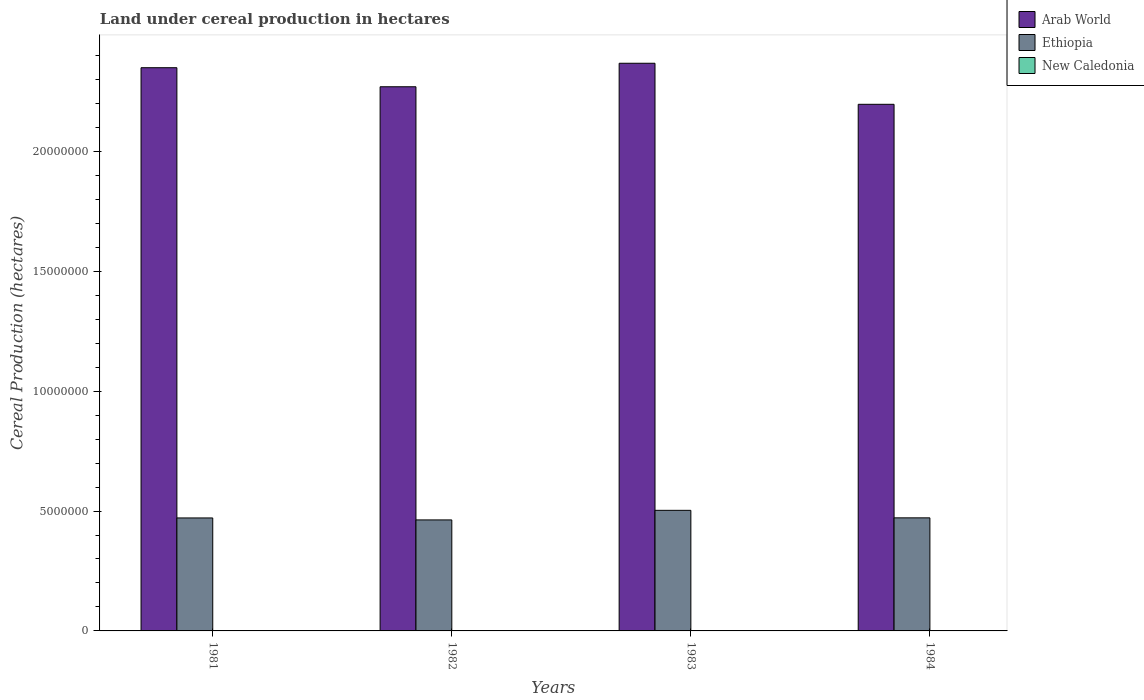Are the number of bars per tick equal to the number of legend labels?
Offer a terse response. Yes. Are the number of bars on each tick of the X-axis equal?
Offer a very short reply. Yes. How many bars are there on the 3rd tick from the left?
Keep it short and to the point. 3. What is the land under cereal production in Arab World in 1984?
Give a very brief answer. 2.20e+07. Across all years, what is the maximum land under cereal production in Ethiopia?
Offer a very short reply. 5.03e+06. Across all years, what is the minimum land under cereal production in Arab World?
Offer a very short reply. 2.20e+07. In which year was the land under cereal production in Arab World maximum?
Provide a short and direct response. 1983. What is the total land under cereal production in Arab World in the graph?
Your answer should be very brief. 9.18e+07. What is the difference between the land under cereal production in Ethiopia in 1982 and that in 1983?
Your response must be concise. -4.00e+05. What is the difference between the land under cereal production in Arab World in 1982 and the land under cereal production in New Caledonia in 1984?
Offer a very short reply. 2.27e+07. What is the average land under cereal production in New Caledonia per year?
Make the answer very short. 1174.75. In the year 1984, what is the difference between the land under cereal production in New Caledonia and land under cereal production in Arab World?
Your answer should be compact. -2.20e+07. In how many years, is the land under cereal production in Ethiopia greater than 16000000 hectares?
Give a very brief answer. 0. What is the ratio of the land under cereal production in Ethiopia in 1982 to that in 1983?
Make the answer very short. 0.92. Is the land under cereal production in Arab World in 1983 less than that in 1984?
Ensure brevity in your answer.  No. Is the difference between the land under cereal production in New Caledonia in 1982 and 1984 greater than the difference between the land under cereal production in Arab World in 1982 and 1984?
Offer a terse response. No. What is the difference between the highest and the second highest land under cereal production in New Caledonia?
Give a very brief answer. 60. What is the difference between the highest and the lowest land under cereal production in Ethiopia?
Offer a terse response. 4.00e+05. In how many years, is the land under cereal production in New Caledonia greater than the average land under cereal production in New Caledonia taken over all years?
Give a very brief answer. 2. What does the 1st bar from the left in 1982 represents?
Offer a terse response. Arab World. What does the 3rd bar from the right in 1983 represents?
Your answer should be compact. Arab World. What is the difference between two consecutive major ticks on the Y-axis?
Ensure brevity in your answer.  5.00e+06. Does the graph contain any zero values?
Ensure brevity in your answer.  No. Where does the legend appear in the graph?
Ensure brevity in your answer.  Top right. How many legend labels are there?
Give a very brief answer. 3. What is the title of the graph?
Provide a succinct answer. Land under cereal production in hectares. Does "India" appear as one of the legend labels in the graph?
Give a very brief answer. No. What is the label or title of the Y-axis?
Provide a short and direct response. Cereal Production (hectares). What is the Cereal Production (hectares) in Arab World in 1981?
Give a very brief answer. 2.35e+07. What is the Cereal Production (hectares) of Ethiopia in 1981?
Give a very brief answer. 4.71e+06. What is the Cereal Production (hectares) in New Caledonia in 1981?
Offer a very short reply. 1191. What is the Cereal Production (hectares) in Arab World in 1982?
Make the answer very short. 2.27e+07. What is the Cereal Production (hectares) of Ethiopia in 1982?
Your answer should be compact. 4.63e+06. What is the Cereal Production (hectares) of New Caledonia in 1982?
Offer a very short reply. 1251. What is the Cereal Production (hectares) of Arab World in 1983?
Your answer should be very brief. 2.37e+07. What is the Cereal Production (hectares) of Ethiopia in 1983?
Provide a short and direct response. 5.03e+06. What is the Cereal Production (hectares) in New Caledonia in 1983?
Ensure brevity in your answer.  1162. What is the Cereal Production (hectares) in Arab World in 1984?
Your response must be concise. 2.20e+07. What is the Cereal Production (hectares) in Ethiopia in 1984?
Offer a very short reply. 4.72e+06. What is the Cereal Production (hectares) in New Caledonia in 1984?
Ensure brevity in your answer.  1095. Across all years, what is the maximum Cereal Production (hectares) of Arab World?
Your answer should be very brief. 2.37e+07. Across all years, what is the maximum Cereal Production (hectares) of Ethiopia?
Your answer should be very brief. 5.03e+06. Across all years, what is the maximum Cereal Production (hectares) in New Caledonia?
Your answer should be compact. 1251. Across all years, what is the minimum Cereal Production (hectares) in Arab World?
Keep it short and to the point. 2.20e+07. Across all years, what is the minimum Cereal Production (hectares) in Ethiopia?
Your answer should be very brief. 4.63e+06. Across all years, what is the minimum Cereal Production (hectares) in New Caledonia?
Ensure brevity in your answer.  1095. What is the total Cereal Production (hectares) in Arab World in the graph?
Ensure brevity in your answer.  9.18e+07. What is the total Cereal Production (hectares) of Ethiopia in the graph?
Make the answer very short. 1.91e+07. What is the total Cereal Production (hectares) in New Caledonia in the graph?
Your answer should be compact. 4699. What is the difference between the Cereal Production (hectares) in Arab World in 1981 and that in 1982?
Your answer should be compact. 7.95e+05. What is the difference between the Cereal Production (hectares) of Ethiopia in 1981 and that in 1982?
Provide a succinct answer. 8.24e+04. What is the difference between the Cereal Production (hectares) in New Caledonia in 1981 and that in 1982?
Your response must be concise. -60. What is the difference between the Cereal Production (hectares) of Arab World in 1981 and that in 1983?
Offer a terse response. -1.85e+05. What is the difference between the Cereal Production (hectares) of Ethiopia in 1981 and that in 1983?
Provide a succinct answer. -3.17e+05. What is the difference between the Cereal Production (hectares) of New Caledonia in 1981 and that in 1983?
Provide a short and direct response. 29. What is the difference between the Cereal Production (hectares) in Arab World in 1981 and that in 1984?
Provide a succinct answer. 1.53e+06. What is the difference between the Cereal Production (hectares) of Ethiopia in 1981 and that in 1984?
Provide a short and direct response. -4040. What is the difference between the Cereal Production (hectares) of New Caledonia in 1981 and that in 1984?
Make the answer very short. 96. What is the difference between the Cereal Production (hectares) in Arab World in 1982 and that in 1983?
Provide a succinct answer. -9.80e+05. What is the difference between the Cereal Production (hectares) of Ethiopia in 1982 and that in 1983?
Ensure brevity in your answer.  -4.00e+05. What is the difference between the Cereal Production (hectares) of New Caledonia in 1982 and that in 1983?
Provide a succinct answer. 89. What is the difference between the Cereal Production (hectares) in Arab World in 1982 and that in 1984?
Offer a very short reply. 7.31e+05. What is the difference between the Cereal Production (hectares) in Ethiopia in 1982 and that in 1984?
Make the answer very short. -8.64e+04. What is the difference between the Cereal Production (hectares) in New Caledonia in 1982 and that in 1984?
Ensure brevity in your answer.  156. What is the difference between the Cereal Production (hectares) in Arab World in 1983 and that in 1984?
Offer a very short reply. 1.71e+06. What is the difference between the Cereal Production (hectares) of Ethiopia in 1983 and that in 1984?
Provide a succinct answer. 3.13e+05. What is the difference between the Cereal Production (hectares) of Arab World in 1981 and the Cereal Production (hectares) of Ethiopia in 1982?
Ensure brevity in your answer.  1.89e+07. What is the difference between the Cereal Production (hectares) in Arab World in 1981 and the Cereal Production (hectares) in New Caledonia in 1982?
Keep it short and to the point. 2.35e+07. What is the difference between the Cereal Production (hectares) of Ethiopia in 1981 and the Cereal Production (hectares) of New Caledonia in 1982?
Your answer should be compact. 4.71e+06. What is the difference between the Cereal Production (hectares) in Arab World in 1981 and the Cereal Production (hectares) in Ethiopia in 1983?
Make the answer very short. 1.85e+07. What is the difference between the Cereal Production (hectares) in Arab World in 1981 and the Cereal Production (hectares) in New Caledonia in 1983?
Your answer should be compact. 2.35e+07. What is the difference between the Cereal Production (hectares) in Ethiopia in 1981 and the Cereal Production (hectares) in New Caledonia in 1983?
Offer a very short reply. 4.71e+06. What is the difference between the Cereal Production (hectares) in Arab World in 1981 and the Cereal Production (hectares) in Ethiopia in 1984?
Ensure brevity in your answer.  1.88e+07. What is the difference between the Cereal Production (hectares) in Arab World in 1981 and the Cereal Production (hectares) in New Caledonia in 1984?
Provide a succinct answer. 2.35e+07. What is the difference between the Cereal Production (hectares) in Ethiopia in 1981 and the Cereal Production (hectares) in New Caledonia in 1984?
Provide a succinct answer. 4.71e+06. What is the difference between the Cereal Production (hectares) in Arab World in 1982 and the Cereal Production (hectares) in Ethiopia in 1983?
Ensure brevity in your answer.  1.77e+07. What is the difference between the Cereal Production (hectares) of Arab World in 1982 and the Cereal Production (hectares) of New Caledonia in 1983?
Provide a short and direct response. 2.27e+07. What is the difference between the Cereal Production (hectares) in Ethiopia in 1982 and the Cereal Production (hectares) in New Caledonia in 1983?
Your answer should be very brief. 4.63e+06. What is the difference between the Cereal Production (hectares) of Arab World in 1982 and the Cereal Production (hectares) of Ethiopia in 1984?
Your response must be concise. 1.80e+07. What is the difference between the Cereal Production (hectares) of Arab World in 1982 and the Cereal Production (hectares) of New Caledonia in 1984?
Your answer should be very brief. 2.27e+07. What is the difference between the Cereal Production (hectares) of Ethiopia in 1982 and the Cereal Production (hectares) of New Caledonia in 1984?
Offer a terse response. 4.63e+06. What is the difference between the Cereal Production (hectares) in Arab World in 1983 and the Cereal Production (hectares) in Ethiopia in 1984?
Your response must be concise. 1.90e+07. What is the difference between the Cereal Production (hectares) in Arab World in 1983 and the Cereal Production (hectares) in New Caledonia in 1984?
Your answer should be very brief. 2.37e+07. What is the difference between the Cereal Production (hectares) in Ethiopia in 1983 and the Cereal Production (hectares) in New Caledonia in 1984?
Your response must be concise. 5.03e+06. What is the average Cereal Production (hectares) of Arab World per year?
Your response must be concise. 2.30e+07. What is the average Cereal Production (hectares) of Ethiopia per year?
Provide a succinct answer. 4.77e+06. What is the average Cereal Production (hectares) of New Caledonia per year?
Ensure brevity in your answer.  1174.75. In the year 1981, what is the difference between the Cereal Production (hectares) in Arab World and Cereal Production (hectares) in Ethiopia?
Ensure brevity in your answer.  1.88e+07. In the year 1981, what is the difference between the Cereal Production (hectares) in Arab World and Cereal Production (hectares) in New Caledonia?
Keep it short and to the point. 2.35e+07. In the year 1981, what is the difference between the Cereal Production (hectares) of Ethiopia and Cereal Production (hectares) of New Caledonia?
Your answer should be very brief. 4.71e+06. In the year 1982, what is the difference between the Cereal Production (hectares) of Arab World and Cereal Production (hectares) of Ethiopia?
Offer a very short reply. 1.81e+07. In the year 1982, what is the difference between the Cereal Production (hectares) of Arab World and Cereal Production (hectares) of New Caledonia?
Keep it short and to the point. 2.27e+07. In the year 1982, what is the difference between the Cereal Production (hectares) of Ethiopia and Cereal Production (hectares) of New Caledonia?
Offer a very short reply. 4.63e+06. In the year 1983, what is the difference between the Cereal Production (hectares) in Arab World and Cereal Production (hectares) in Ethiopia?
Make the answer very short. 1.86e+07. In the year 1983, what is the difference between the Cereal Production (hectares) of Arab World and Cereal Production (hectares) of New Caledonia?
Your answer should be compact. 2.37e+07. In the year 1983, what is the difference between the Cereal Production (hectares) in Ethiopia and Cereal Production (hectares) in New Caledonia?
Your response must be concise. 5.03e+06. In the year 1984, what is the difference between the Cereal Production (hectares) of Arab World and Cereal Production (hectares) of Ethiopia?
Give a very brief answer. 1.72e+07. In the year 1984, what is the difference between the Cereal Production (hectares) of Arab World and Cereal Production (hectares) of New Caledonia?
Offer a very short reply. 2.20e+07. In the year 1984, what is the difference between the Cereal Production (hectares) in Ethiopia and Cereal Production (hectares) in New Caledonia?
Your answer should be compact. 4.71e+06. What is the ratio of the Cereal Production (hectares) of Arab World in 1981 to that in 1982?
Make the answer very short. 1.03. What is the ratio of the Cereal Production (hectares) of Ethiopia in 1981 to that in 1982?
Offer a very short reply. 1.02. What is the ratio of the Cereal Production (hectares) in Ethiopia in 1981 to that in 1983?
Offer a terse response. 0.94. What is the ratio of the Cereal Production (hectares) in New Caledonia in 1981 to that in 1983?
Make the answer very short. 1.02. What is the ratio of the Cereal Production (hectares) of Arab World in 1981 to that in 1984?
Make the answer very short. 1.07. What is the ratio of the Cereal Production (hectares) of Ethiopia in 1981 to that in 1984?
Give a very brief answer. 1. What is the ratio of the Cereal Production (hectares) of New Caledonia in 1981 to that in 1984?
Your response must be concise. 1.09. What is the ratio of the Cereal Production (hectares) of Arab World in 1982 to that in 1983?
Offer a terse response. 0.96. What is the ratio of the Cereal Production (hectares) in Ethiopia in 1982 to that in 1983?
Provide a short and direct response. 0.92. What is the ratio of the Cereal Production (hectares) of New Caledonia in 1982 to that in 1983?
Offer a terse response. 1.08. What is the ratio of the Cereal Production (hectares) in Arab World in 1982 to that in 1984?
Keep it short and to the point. 1.03. What is the ratio of the Cereal Production (hectares) of Ethiopia in 1982 to that in 1984?
Your response must be concise. 0.98. What is the ratio of the Cereal Production (hectares) in New Caledonia in 1982 to that in 1984?
Your answer should be very brief. 1.14. What is the ratio of the Cereal Production (hectares) in Arab World in 1983 to that in 1984?
Ensure brevity in your answer.  1.08. What is the ratio of the Cereal Production (hectares) in Ethiopia in 1983 to that in 1984?
Offer a very short reply. 1.07. What is the ratio of the Cereal Production (hectares) in New Caledonia in 1983 to that in 1984?
Provide a short and direct response. 1.06. What is the difference between the highest and the second highest Cereal Production (hectares) in Arab World?
Provide a short and direct response. 1.85e+05. What is the difference between the highest and the second highest Cereal Production (hectares) of Ethiopia?
Ensure brevity in your answer.  3.13e+05. What is the difference between the highest and the lowest Cereal Production (hectares) of Arab World?
Provide a succinct answer. 1.71e+06. What is the difference between the highest and the lowest Cereal Production (hectares) in Ethiopia?
Provide a succinct answer. 4.00e+05. What is the difference between the highest and the lowest Cereal Production (hectares) of New Caledonia?
Provide a short and direct response. 156. 